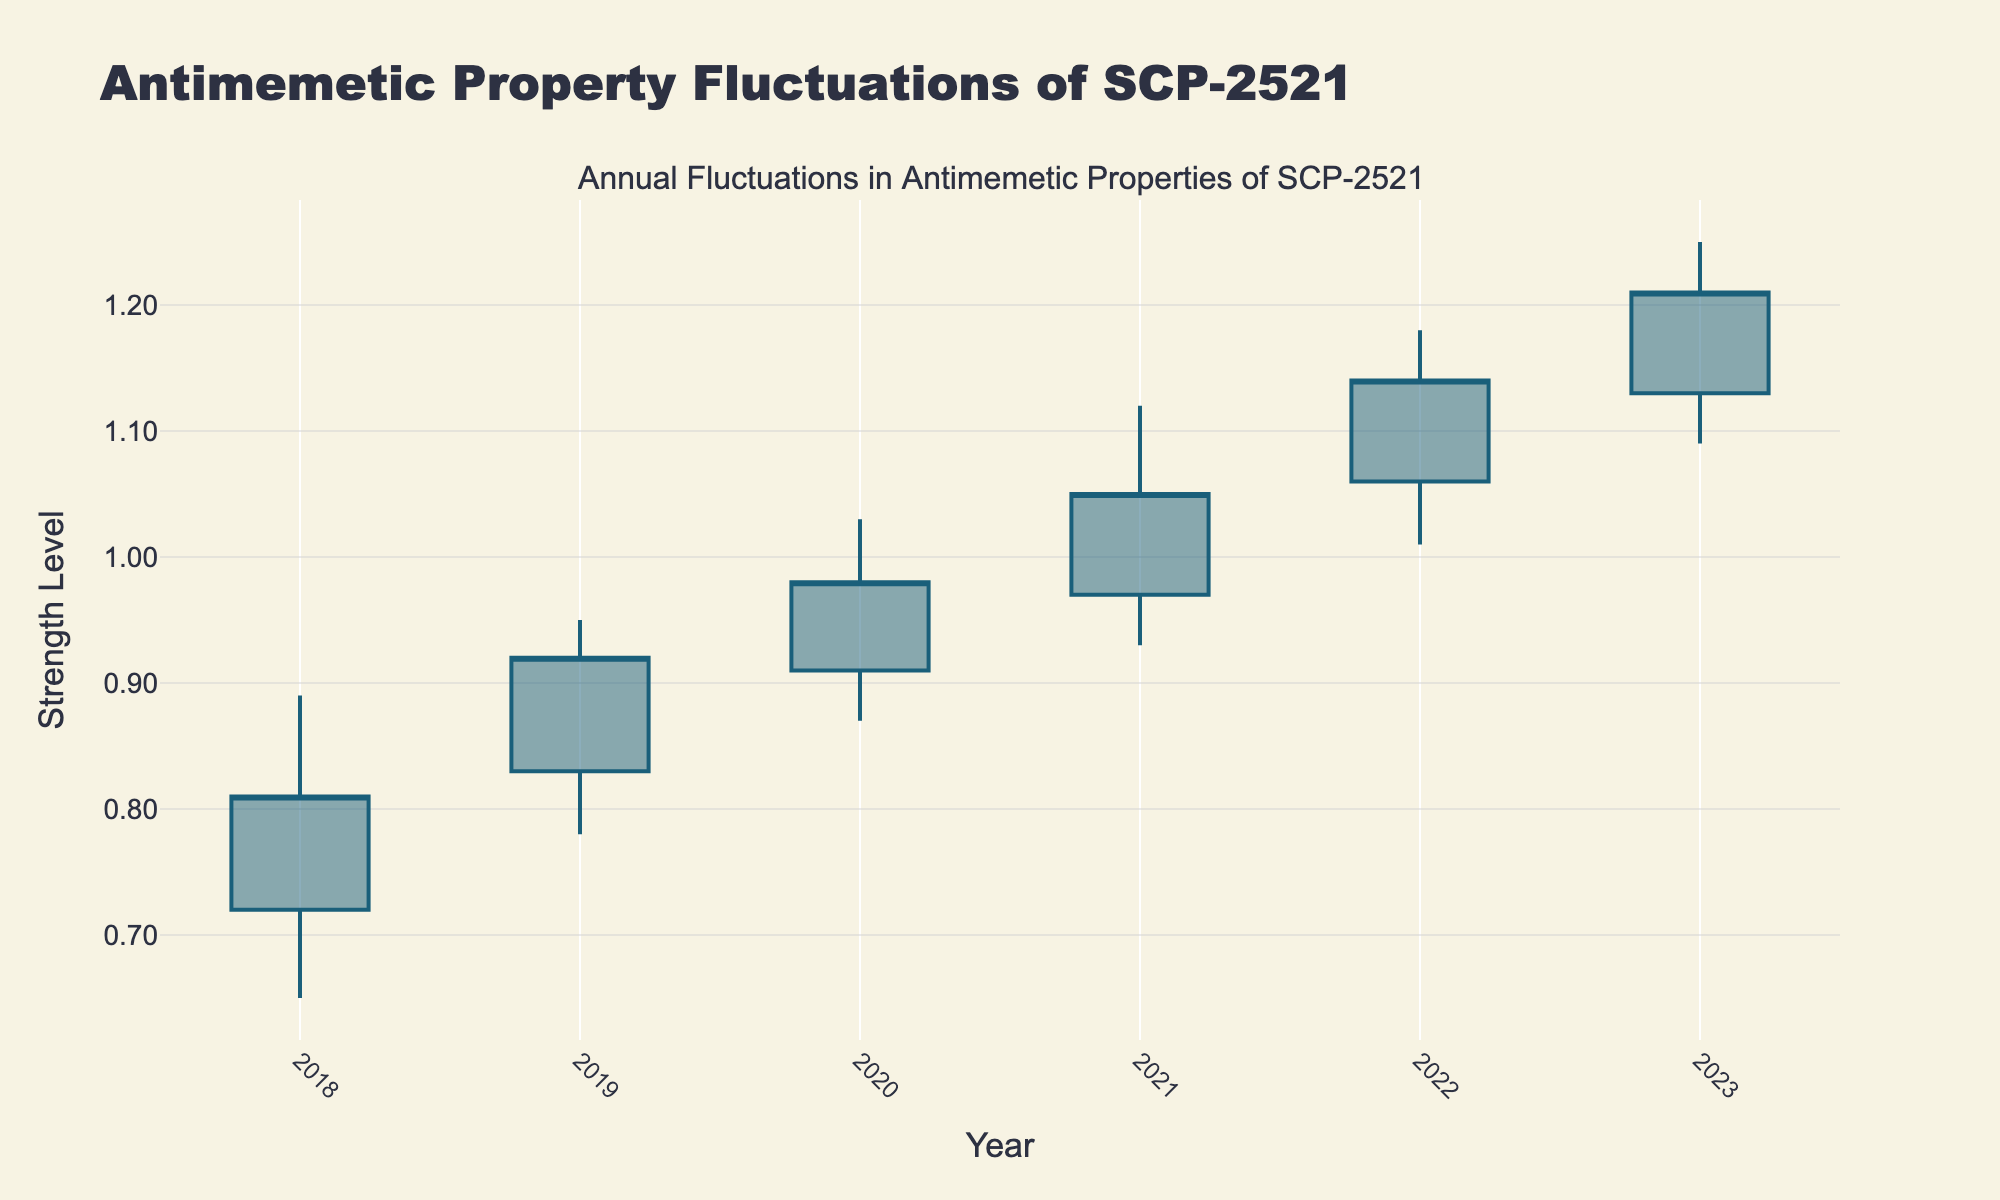What is the title of the figure? The title of any figure is typically displayed at the top of the plot. In this case, it mentions annual fluctuations in antimemetic properties of SCP-2521.
Answer: Antimemetic Property Fluctuations of SCP-2521 What are the axes labeled with? We need to look for the labels along the horizontal and vertical axes of the figure. The x-axis typically represents the independent variable (Year), and the y-axis represents the dependent variable (Strength Level).
Answer: Year and Strength Level How many years of data are presented in the figure? The x-axis should list all the years for which data is available. Counting these entries will give us the total number of years.
Answer: Six Which year saw the highest maximum strength level recorded? To determine this, we look for the highest "High" value among all the candlesticks and note which year it corresponds to.
Answer: 2021 In which year was the closing strength level the highest? Identify the candlestick with the highest closing value by comparing the "Closing" values for each year.
Answer: 2023 What is the range of strength levels in 2019? The range is determined by subtracting the minimum strength level (Low) from the maximum strength level (High) for 2019. So, it's 0.95 - 0.78.
Answer: 0.17 Comparing 2018 and 2020, in which year did the antimemetic strength of SCP-2521 have a higher low value? Check the "Low" values for both years and identify which one is greater.
Answer: 2020 What is the average closing strength level over the six years? Add up the closing values for all six years and then divide by the number of years (6). The values are (0.81 + 0.92 + 0.98 + 1.05 + 1.14 + 1.21). The calculation is (0.81 + 0.92 + 0.98 + 1.05 + 1.14 + 1.21) / 6.
Answer: 1.0183 How did the closing strength level change from 2018 to 2023? Subtract the closing level in 2018 (0.81) from the closing level in 2023 (1.21). The change is calculated as 1.21 - 0.81.
Answer: Increased by 0.40 What is the median opening strength level for the six years? List the opening values (0.72, 0.83, 0.91, 0.97, 1.06, 1.13) in order and find the middle value or the average of the two middle values if there are an even number of points. For this dataset, the middle values are 0.91 and 0.97. The median is (0.91 + 0.97) / 2.
Answer: 0.94 